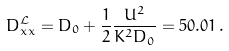Convert formula to latex. <formula><loc_0><loc_0><loc_500><loc_500>D ^ { \mathcal { L } } _ { x x } = D _ { 0 } + \frac { 1 } { 2 } \frac { U ^ { 2 } } { K ^ { 2 } D _ { 0 } } = 5 0 . 0 1 \, .</formula> 